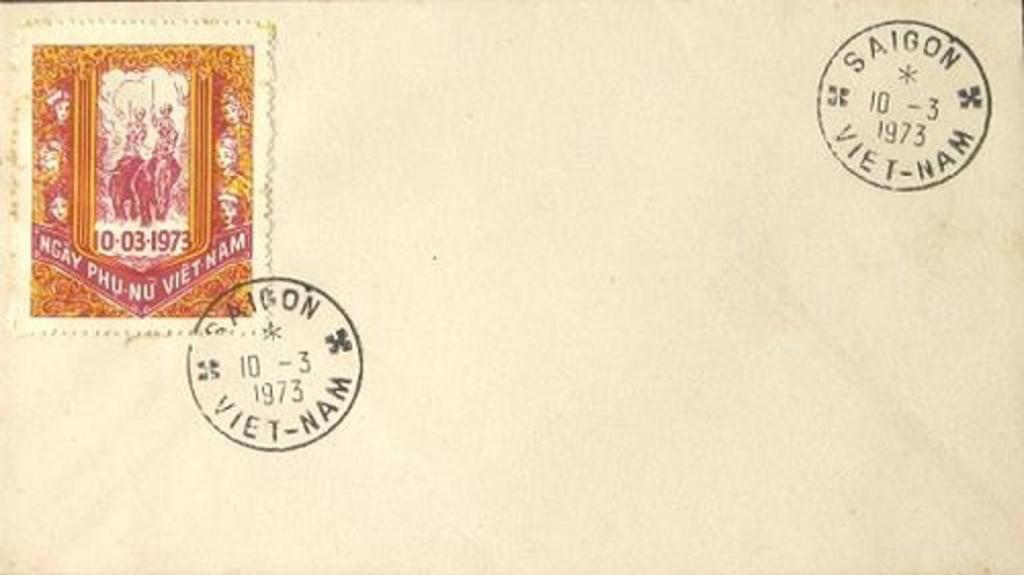<image>
Give a short and clear explanation of the subsequent image. A letter bears postmarks from Saigon in Vietnam. 